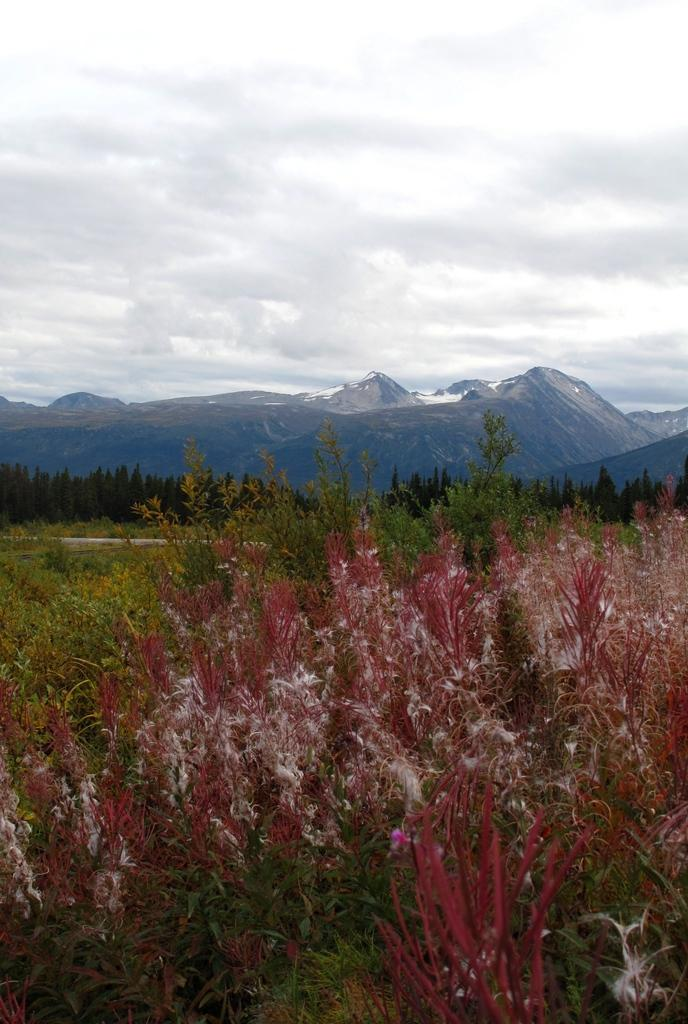What type of vegetation is present at the bottom of the image? There are plants on the ground at the bottom of the image. What can be seen in the background of the image? There are trees, mountains, and clouds in the background of the image. What is the rate of the mine in the image? There is no mine present in the image, so it is not possible to determine a rate. 